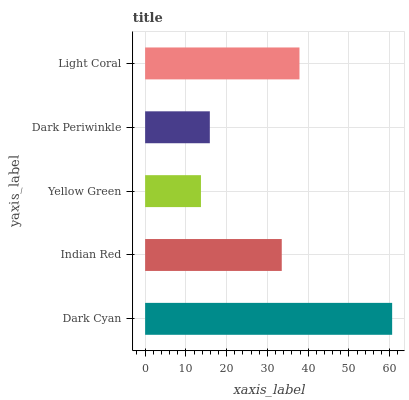Is Yellow Green the minimum?
Answer yes or no. Yes. Is Dark Cyan the maximum?
Answer yes or no. Yes. Is Indian Red the minimum?
Answer yes or no. No. Is Indian Red the maximum?
Answer yes or no. No. Is Dark Cyan greater than Indian Red?
Answer yes or no. Yes. Is Indian Red less than Dark Cyan?
Answer yes or no. Yes. Is Indian Red greater than Dark Cyan?
Answer yes or no. No. Is Dark Cyan less than Indian Red?
Answer yes or no. No. Is Indian Red the high median?
Answer yes or no. Yes. Is Indian Red the low median?
Answer yes or no. Yes. Is Dark Periwinkle the high median?
Answer yes or no. No. Is Light Coral the low median?
Answer yes or no. No. 